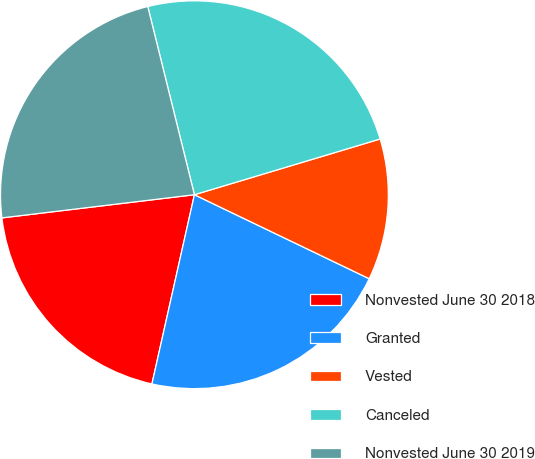Convert chart to OTSL. <chart><loc_0><loc_0><loc_500><loc_500><pie_chart><fcel>Nonvested June 30 2018<fcel>Granted<fcel>Vested<fcel>Canceled<fcel>Nonvested June 30 2019<nl><fcel>19.58%<fcel>21.39%<fcel>11.77%<fcel>24.23%<fcel>23.04%<nl></chart> 